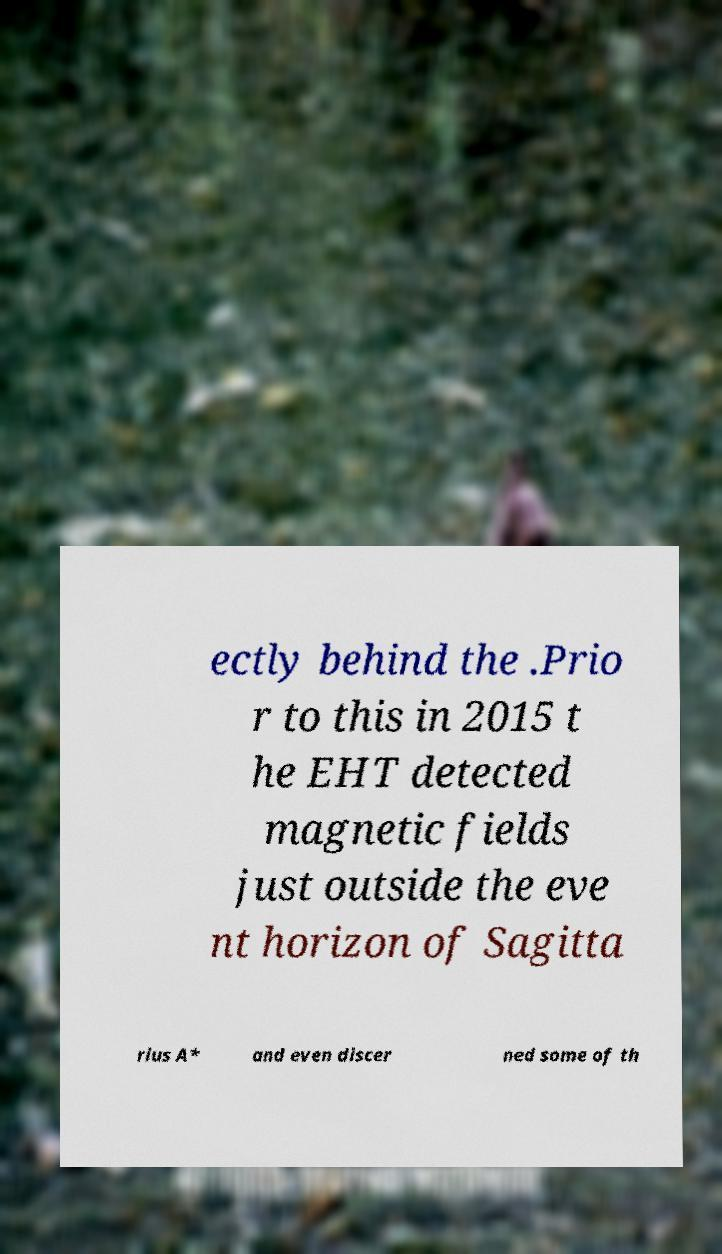What messages or text are displayed in this image? I need them in a readable, typed format. ectly behind the .Prio r to this in 2015 t he EHT detected magnetic fields just outside the eve nt horizon of Sagitta rius A* and even discer ned some of th 